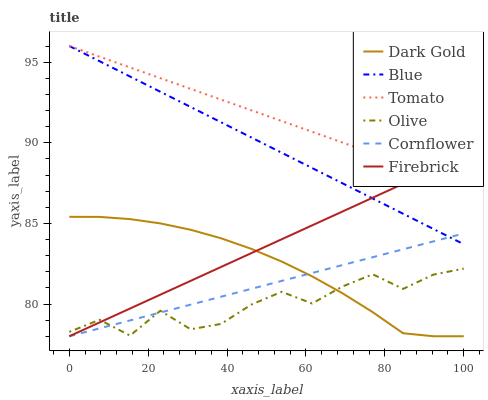Does Olive have the minimum area under the curve?
Answer yes or no. Yes. Does Tomato have the maximum area under the curve?
Answer yes or no. Yes. Does Cornflower have the minimum area under the curve?
Answer yes or no. No. Does Cornflower have the maximum area under the curve?
Answer yes or no. No. Is Blue the smoothest?
Answer yes or no. Yes. Is Olive the roughest?
Answer yes or no. Yes. Is Tomato the smoothest?
Answer yes or no. No. Is Tomato the roughest?
Answer yes or no. No. Does Cornflower have the lowest value?
Answer yes or no. Yes. Does Tomato have the lowest value?
Answer yes or no. No. Does Tomato have the highest value?
Answer yes or no. Yes. Does Cornflower have the highest value?
Answer yes or no. No. Is Dark Gold less than Tomato?
Answer yes or no. Yes. Is Tomato greater than Cornflower?
Answer yes or no. Yes. Does Blue intersect Tomato?
Answer yes or no. Yes. Is Blue less than Tomato?
Answer yes or no. No. Is Blue greater than Tomato?
Answer yes or no. No. Does Dark Gold intersect Tomato?
Answer yes or no. No. 